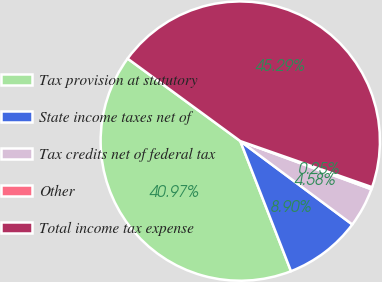<chart> <loc_0><loc_0><loc_500><loc_500><pie_chart><fcel>Tax provision at statutory<fcel>State income taxes net of<fcel>Tax credits net of federal tax<fcel>Other<fcel>Total income tax expense<nl><fcel>40.97%<fcel>8.9%<fcel>4.58%<fcel>0.25%<fcel>45.29%<nl></chart> 